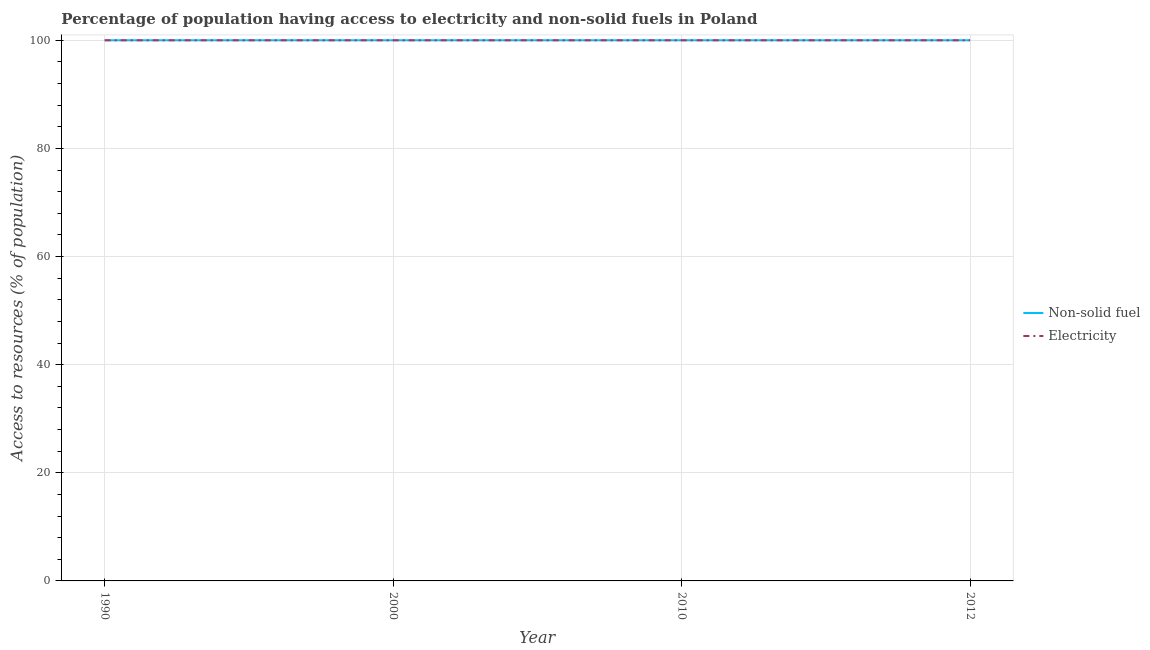Does the line corresponding to percentage of population having access to non-solid fuel intersect with the line corresponding to percentage of population having access to electricity?
Your answer should be very brief. Yes. What is the percentage of population having access to electricity in 2010?
Your response must be concise. 100. Across all years, what is the maximum percentage of population having access to electricity?
Provide a short and direct response. 100. Across all years, what is the minimum percentage of population having access to non-solid fuel?
Give a very brief answer. 100. In which year was the percentage of population having access to non-solid fuel maximum?
Your answer should be compact. 1990. In which year was the percentage of population having access to non-solid fuel minimum?
Ensure brevity in your answer.  1990. What is the total percentage of population having access to non-solid fuel in the graph?
Provide a succinct answer. 400. Is the difference between the percentage of population having access to electricity in 2010 and 2012 greater than the difference between the percentage of population having access to non-solid fuel in 2010 and 2012?
Give a very brief answer. No. What is the difference between the highest and the lowest percentage of population having access to electricity?
Provide a short and direct response. 0. In how many years, is the percentage of population having access to electricity greater than the average percentage of population having access to electricity taken over all years?
Keep it short and to the point. 0. Is the sum of the percentage of population having access to electricity in 2000 and 2012 greater than the maximum percentage of population having access to non-solid fuel across all years?
Offer a very short reply. Yes. Does the percentage of population having access to electricity monotonically increase over the years?
Your answer should be very brief. No. How many years are there in the graph?
Keep it short and to the point. 4. Does the graph contain any zero values?
Make the answer very short. No. How many legend labels are there?
Your response must be concise. 2. How are the legend labels stacked?
Make the answer very short. Vertical. What is the title of the graph?
Keep it short and to the point. Percentage of population having access to electricity and non-solid fuels in Poland. Does "Urban" appear as one of the legend labels in the graph?
Provide a succinct answer. No. What is the label or title of the X-axis?
Offer a very short reply. Year. What is the label or title of the Y-axis?
Your answer should be compact. Access to resources (% of population). What is the Access to resources (% of population) in Non-solid fuel in 2000?
Offer a very short reply. 100. What is the Access to resources (% of population) in Electricity in 2000?
Provide a succinct answer. 100. What is the Access to resources (% of population) of Electricity in 2010?
Offer a terse response. 100. What is the Access to resources (% of population) in Non-solid fuel in 2012?
Your response must be concise. 100. What is the Access to resources (% of population) of Electricity in 2012?
Offer a terse response. 100. Across all years, what is the minimum Access to resources (% of population) in Non-solid fuel?
Provide a succinct answer. 100. Across all years, what is the minimum Access to resources (% of population) in Electricity?
Your response must be concise. 100. What is the total Access to resources (% of population) in Non-solid fuel in the graph?
Make the answer very short. 400. What is the total Access to resources (% of population) of Electricity in the graph?
Your answer should be compact. 400. What is the difference between the Access to resources (% of population) in Non-solid fuel in 1990 and that in 2000?
Provide a short and direct response. 0. What is the difference between the Access to resources (% of population) of Non-solid fuel in 1990 and that in 2010?
Your answer should be very brief. 0. What is the difference between the Access to resources (% of population) in Electricity in 1990 and that in 2010?
Make the answer very short. 0. What is the difference between the Access to resources (% of population) of Non-solid fuel in 1990 and that in 2012?
Your answer should be compact. 0. What is the difference between the Access to resources (% of population) in Electricity in 1990 and that in 2012?
Give a very brief answer. 0. What is the difference between the Access to resources (% of population) in Non-solid fuel in 2000 and that in 2010?
Keep it short and to the point. 0. What is the difference between the Access to resources (% of population) of Electricity in 2000 and that in 2010?
Offer a very short reply. 0. What is the difference between the Access to resources (% of population) in Non-solid fuel in 2000 and that in 2012?
Your response must be concise. 0. What is the difference between the Access to resources (% of population) of Electricity in 2000 and that in 2012?
Offer a terse response. 0. What is the difference between the Access to resources (% of population) in Non-solid fuel in 2010 and that in 2012?
Your answer should be compact. 0. What is the difference between the Access to resources (% of population) of Non-solid fuel in 1990 and the Access to resources (% of population) of Electricity in 2000?
Offer a terse response. 0. What is the difference between the Access to resources (% of population) in Non-solid fuel in 1990 and the Access to resources (% of population) in Electricity in 2012?
Your response must be concise. 0. What is the difference between the Access to resources (% of population) of Non-solid fuel in 2000 and the Access to resources (% of population) of Electricity in 2010?
Your answer should be compact. 0. What is the difference between the Access to resources (% of population) of Non-solid fuel in 2000 and the Access to resources (% of population) of Electricity in 2012?
Your answer should be compact. 0. What is the average Access to resources (% of population) in Non-solid fuel per year?
Your response must be concise. 100. What is the average Access to resources (% of population) of Electricity per year?
Provide a short and direct response. 100. In the year 2010, what is the difference between the Access to resources (% of population) in Non-solid fuel and Access to resources (% of population) in Electricity?
Give a very brief answer. 0. In the year 2012, what is the difference between the Access to resources (% of population) in Non-solid fuel and Access to resources (% of population) in Electricity?
Your answer should be compact. 0. What is the ratio of the Access to resources (% of population) in Non-solid fuel in 1990 to that in 2000?
Keep it short and to the point. 1. What is the ratio of the Access to resources (% of population) in Electricity in 1990 to that in 2000?
Your answer should be very brief. 1. What is the ratio of the Access to resources (% of population) of Non-solid fuel in 1990 to that in 2010?
Offer a very short reply. 1. What is the ratio of the Access to resources (% of population) in Electricity in 1990 to that in 2010?
Your answer should be compact. 1. What is the ratio of the Access to resources (% of population) in Electricity in 1990 to that in 2012?
Your answer should be compact. 1. What is the ratio of the Access to resources (% of population) of Electricity in 2000 to that in 2010?
Provide a succinct answer. 1. What is the ratio of the Access to resources (% of population) of Electricity in 2000 to that in 2012?
Give a very brief answer. 1. What is the ratio of the Access to resources (% of population) of Electricity in 2010 to that in 2012?
Make the answer very short. 1. What is the difference between the highest and the lowest Access to resources (% of population) of Electricity?
Keep it short and to the point. 0. 